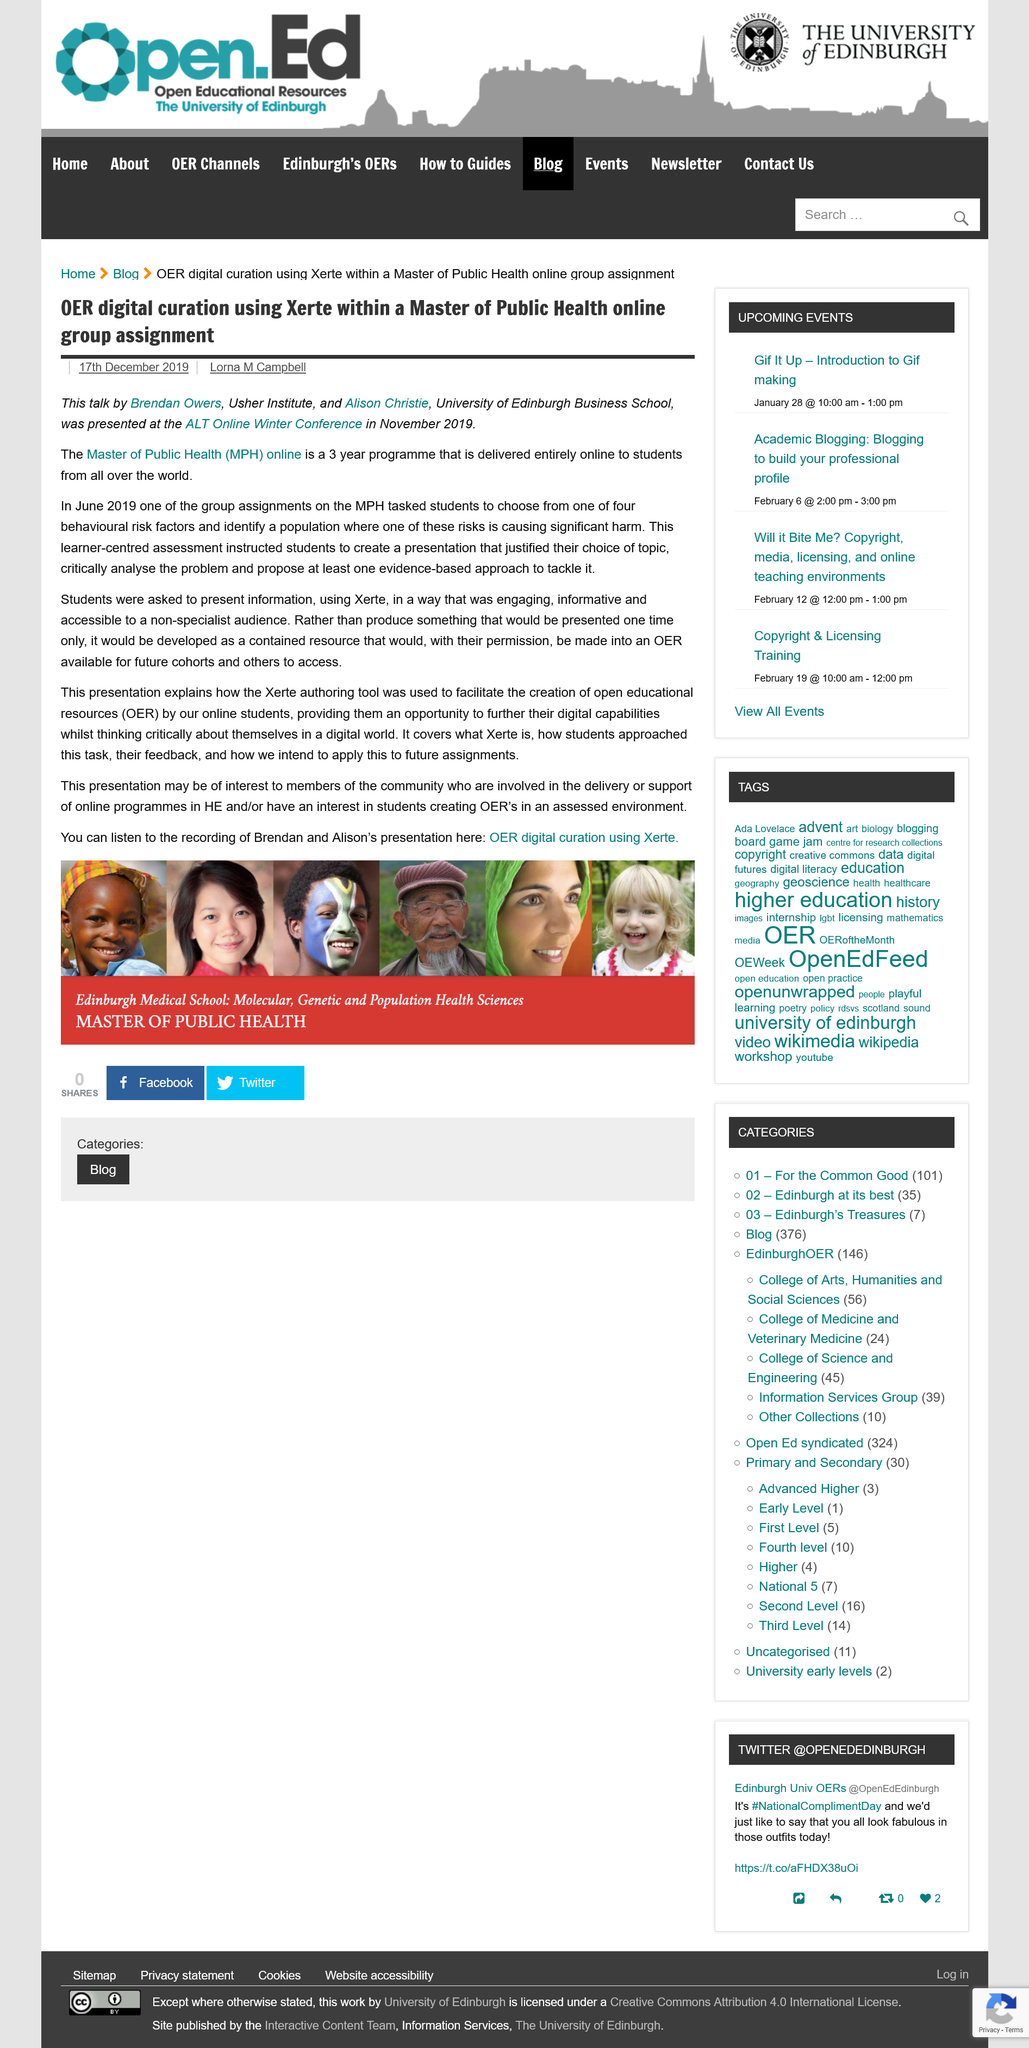Specify some key components in this picture. MPH stands for Master of Public Health, a postgraduate degree designed to prepare individuals for careers in public health practice, research, and leadership. Brendan Owers and Alison Christie gave their talk at the ALT Online Winter Conference, which is the name of the conference. The article, published on December 17, 2019, was written by Lorna M Campbell. 